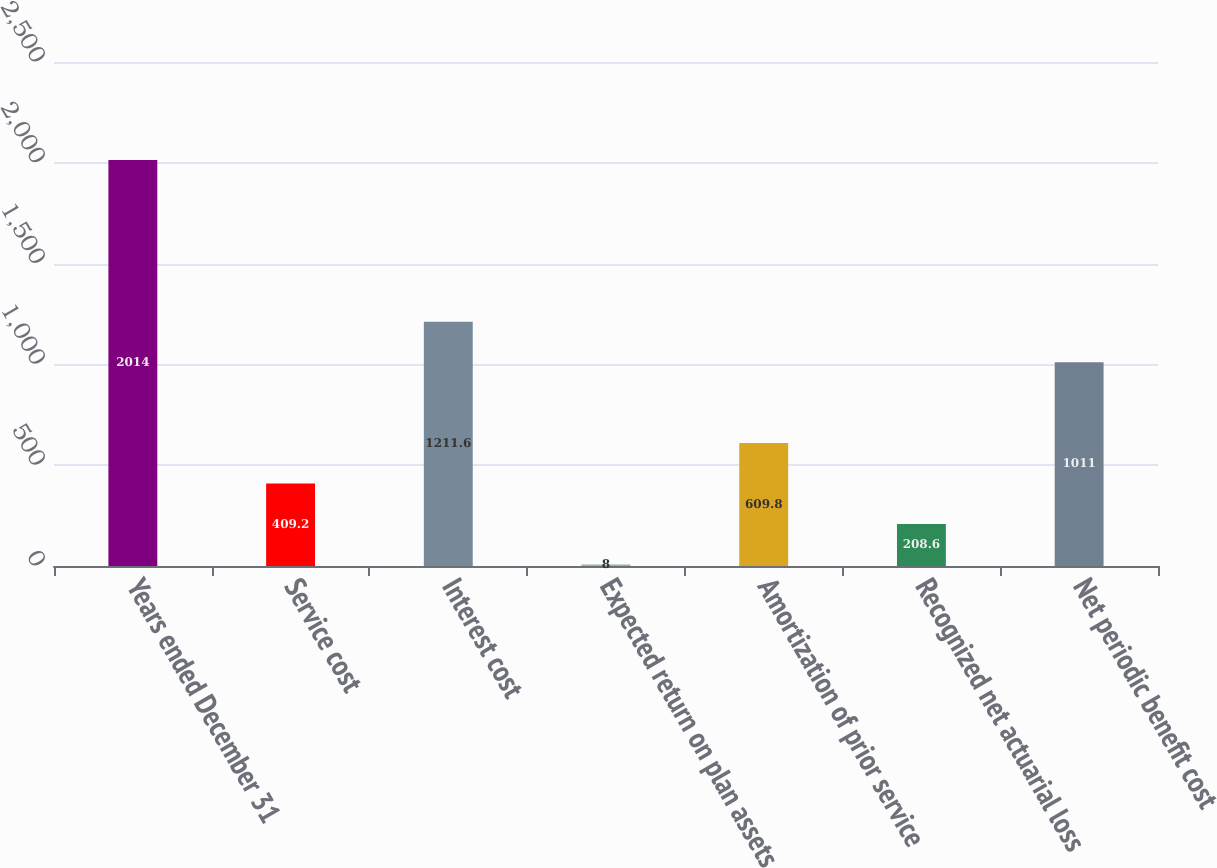Convert chart to OTSL. <chart><loc_0><loc_0><loc_500><loc_500><bar_chart><fcel>Years ended December 31<fcel>Service cost<fcel>Interest cost<fcel>Expected return on plan assets<fcel>Amortization of prior service<fcel>Recognized net actuarial loss<fcel>Net periodic benefit cost<nl><fcel>2014<fcel>409.2<fcel>1211.6<fcel>8<fcel>609.8<fcel>208.6<fcel>1011<nl></chart> 